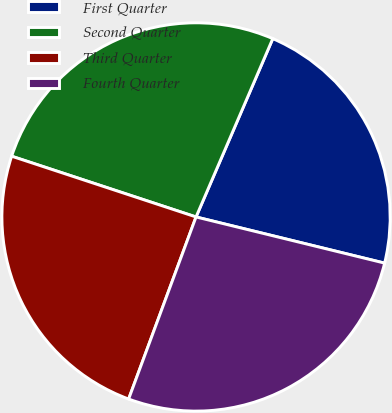<chart> <loc_0><loc_0><loc_500><loc_500><pie_chart><fcel>First Quarter<fcel>Second Quarter<fcel>Third Quarter<fcel>Fourth Quarter<nl><fcel>22.35%<fcel>26.4%<fcel>24.42%<fcel>26.82%<nl></chart> 